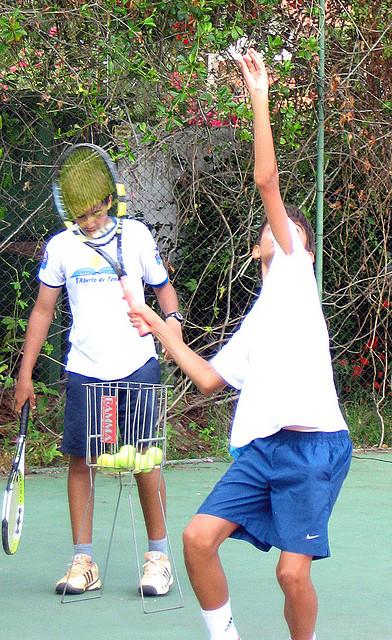Is that a chain linked fence?
Write a very short answer. Yes. What color are the shorts?
Write a very short answer. Blue. What color balls are they playing with?
Quick response, please. Green. What sport are they playing?
Keep it brief. Tennis. 